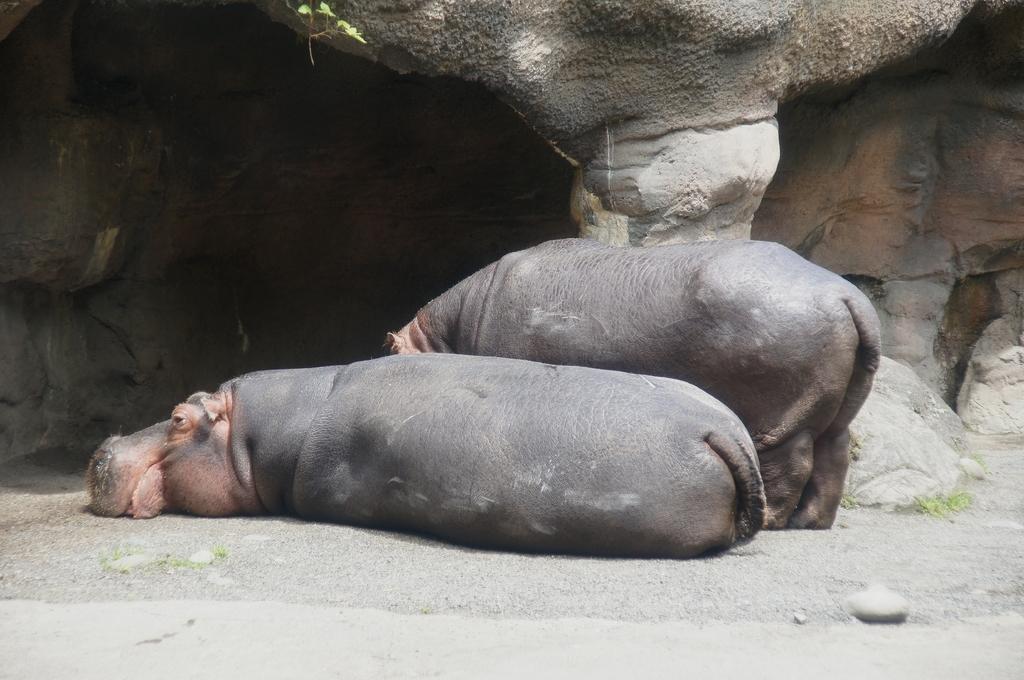Please provide a concise description of this image. In this image we can see hippopotami lying and standing on the ground. In the background there are rocks. 